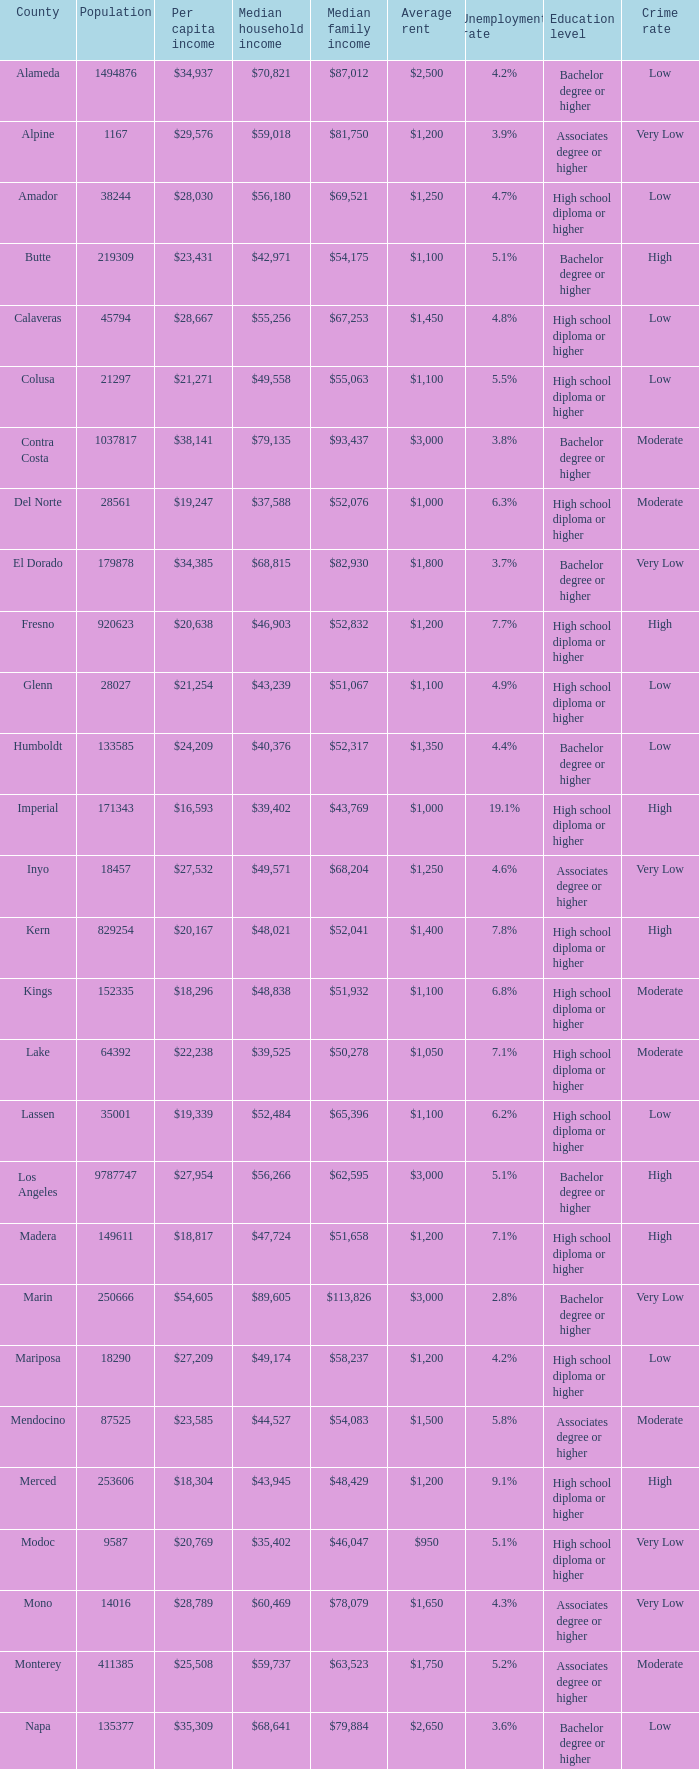What is the middle household income in butte? $42,971. 